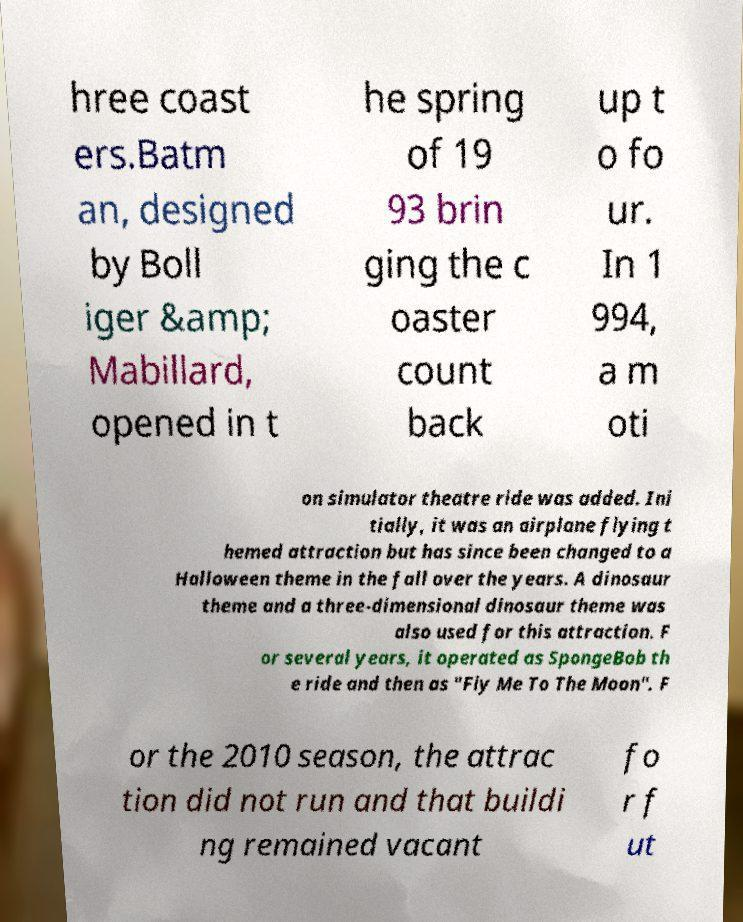Can you read and provide the text displayed in the image?This photo seems to have some interesting text. Can you extract and type it out for me? hree coast ers.Batm an, designed by Boll iger &amp; Mabillard, opened in t he spring of 19 93 brin ging the c oaster count back up t o fo ur. In 1 994, a m oti on simulator theatre ride was added. Ini tially, it was an airplane flying t hemed attraction but has since been changed to a Halloween theme in the fall over the years. A dinosaur theme and a three-dimensional dinosaur theme was also used for this attraction. F or several years, it operated as SpongeBob th e ride and then as "Fly Me To The Moon". F or the 2010 season, the attrac tion did not run and that buildi ng remained vacant fo r f ut 